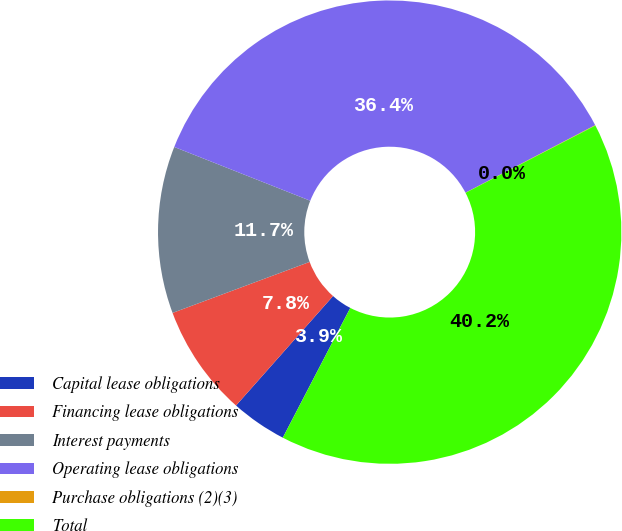Convert chart. <chart><loc_0><loc_0><loc_500><loc_500><pie_chart><fcel>Capital lease obligations<fcel>Financing lease obligations<fcel>Interest payments<fcel>Operating lease obligations<fcel>Purchase obligations (2)(3)<fcel>Total<nl><fcel>3.91%<fcel>7.79%<fcel>11.66%<fcel>36.37%<fcel>0.03%<fcel>40.24%<nl></chart> 